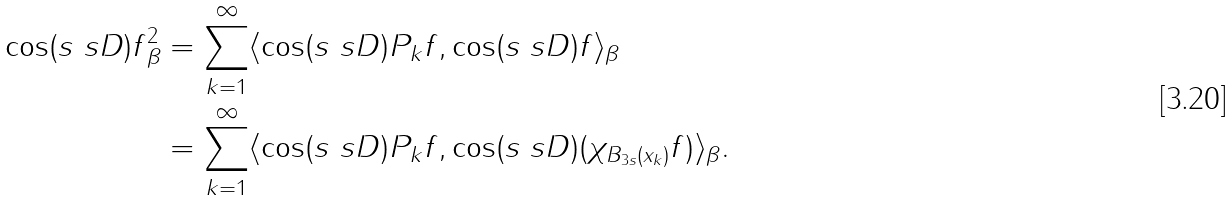<formula> <loc_0><loc_0><loc_500><loc_500>\| \cos ( s \ s D ) f \| ^ { 2 } _ { \beta } & = \sum _ { k = 1 } ^ { \infty } \langle \cos ( s \ s D ) P _ { k } f , \cos ( s \ s D ) f \rangle _ { \beta } \\ & = \sum _ { k = 1 } ^ { \infty } \langle \cos ( s \ s D ) P _ { k } f , \cos ( s \ s D ) ( \chi _ { B _ { 3 s } ( x _ { k } ) } f ) \rangle _ { \beta } .</formula> 